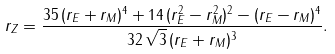<formula> <loc_0><loc_0><loc_500><loc_500>r _ { Z } = \frac { 3 5 \, ( r _ { E } + r _ { M } ) ^ { 4 } + 1 4 \, ( r _ { E } ^ { 2 } - r _ { M } ^ { 2 } ) ^ { 2 } - ( r _ { E } - r _ { M } ) ^ { 4 } } { 3 2 \, \sqrt { 3 } \, ( r _ { E } + r _ { M } ) ^ { 3 } } .</formula> 